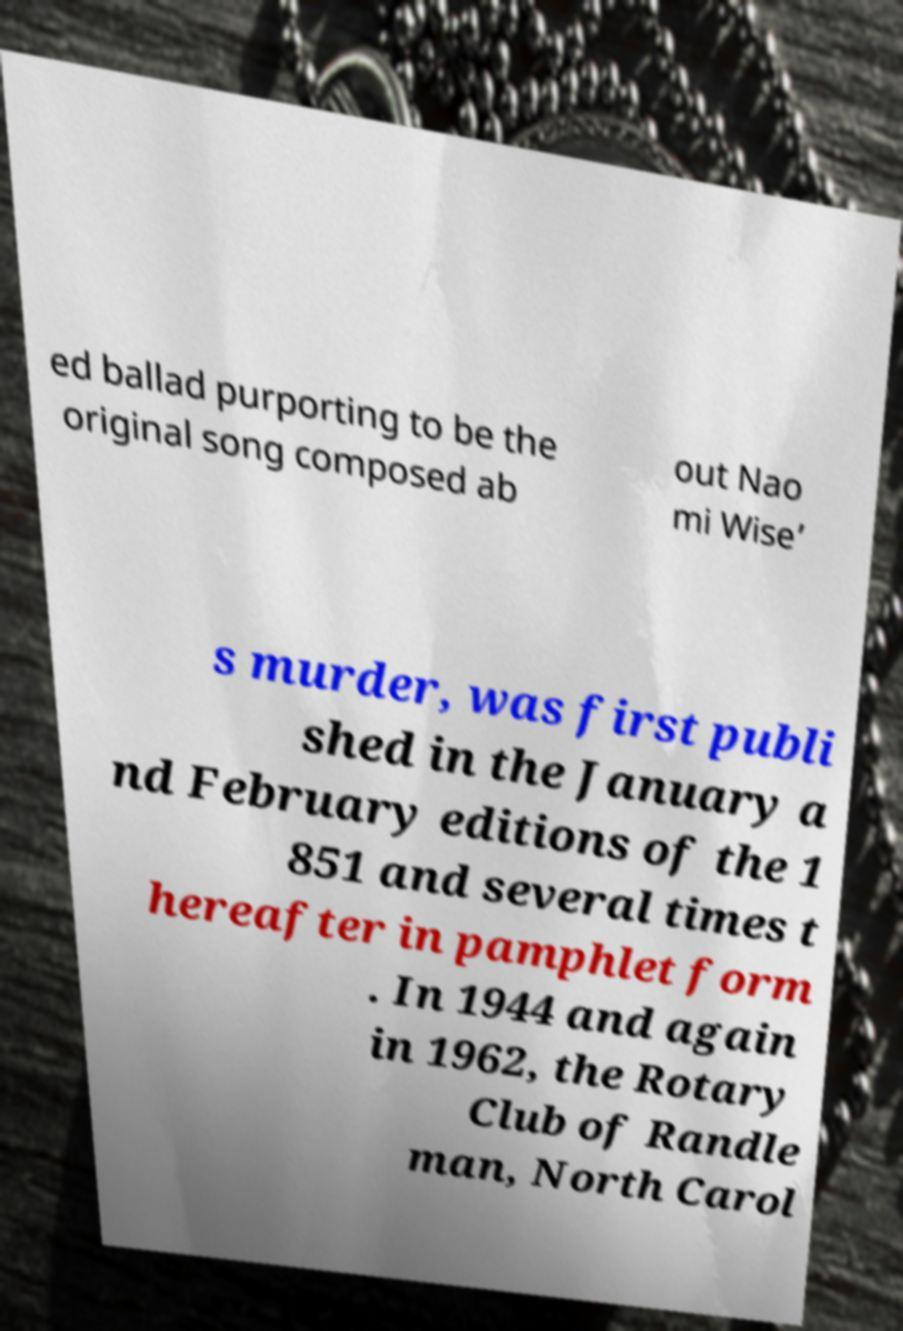Please identify and transcribe the text found in this image. ed ballad purporting to be the original song composed ab out Nao mi Wise’ s murder, was first publi shed in the January a nd February editions of the 1 851 and several times t hereafter in pamphlet form . In 1944 and again in 1962, the Rotary Club of Randle man, North Carol 